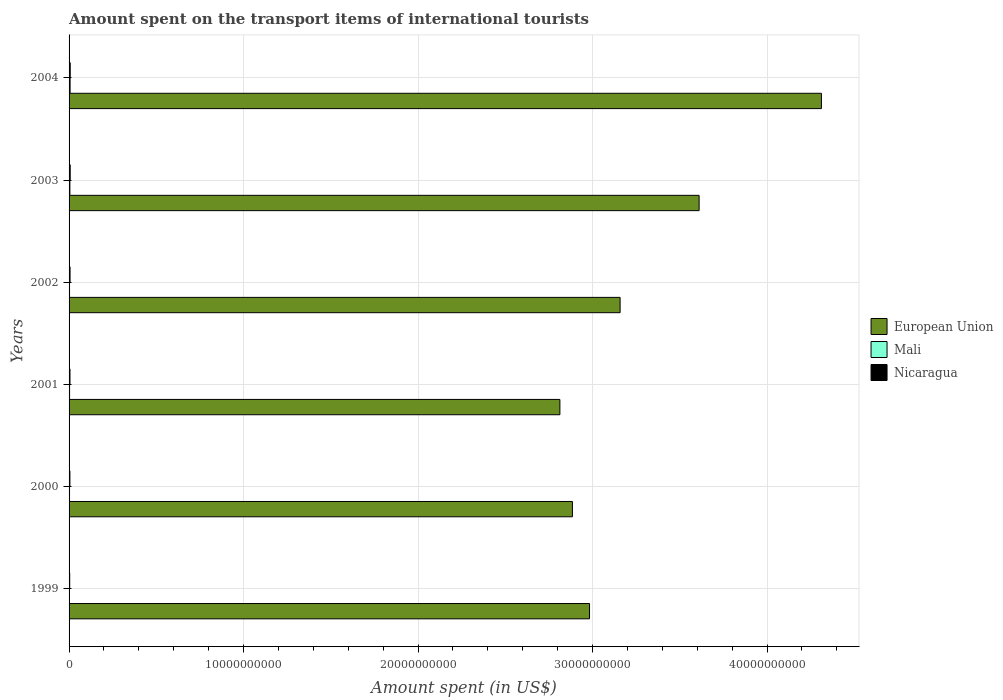How many different coloured bars are there?
Make the answer very short. 3. Are the number of bars per tick equal to the number of legend labels?
Your answer should be compact. Yes. Are the number of bars on each tick of the Y-axis equal?
Provide a short and direct response. Yes. How many bars are there on the 4th tick from the top?
Provide a short and direct response. 3. What is the label of the 4th group of bars from the top?
Give a very brief answer. 2001. In how many cases, is the number of bars for a given year not equal to the number of legend labels?
Give a very brief answer. 0. What is the amount spent on the transport items of international tourists in Mali in 1999?
Offer a very short reply. 2.50e+07. Across all years, what is the maximum amount spent on the transport items of international tourists in Mali?
Provide a short and direct response. 5.90e+07. Across all years, what is the minimum amount spent on the transport items of international tourists in Mali?
Offer a terse response. 2.50e+07. In which year was the amount spent on the transport items of international tourists in European Union minimum?
Offer a terse response. 2001. What is the total amount spent on the transport items of international tourists in Nicaragua in the graph?
Keep it short and to the point. 3.21e+08. What is the difference between the amount spent on the transport items of international tourists in Mali in 1999 and the amount spent on the transport items of international tourists in European Union in 2001?
Your answer should be very brief. -2.81e+1. What is the average amount spent on the transport items of international tourists in Mali per year?
Offer a very short reply. 3.52e+07. In the year 2003, what is the difference between the amount spent on the transport items of international tourists in Mali and amount spent on the transport items of international tourists in Nicaragua?
Provide a succinct answer. -1.80e+07. What is the ratio of the amount spent on the transport items of international tourists in European Union in 1999 to that in 2001?
Make the answer very short. 1.06. What is the difference between the highest and the second highest amount spent on the transport items of international tourists in European Union?
Ensure brevity in your answer.  7.01e+09. What is the difference between the highest and the lowest amount spent on the transport items of international tourists in Mali?
Give a very brief answer. 3.40e+07. In how many years, is the amount spent on the transport items of international tourists in Mali greater than the average amount spent on the transport items of international tourists in Mali taken over all years?
Provide a short and direct response. 2. What does the 2nd bar from the top in 2003 represents?
Ensure brevity in your answer.  Mali. What does the 2nd bar from the bottom in 2001 represents?
Ensure brevity in your answer.  Mali. How many years are there in the graph?
Provide a succinct answer. 6. Does the graph contain any zero values?
Ensure brevity in your answer.  No. How are the legend labels stacked?
Your answer should be compact. Vertical. What is the title of the graph?
Make the answer very short. Amount spent on the transport items of international tourists. Does "Tajikistan" appear as one of the legend labels in the graph?
Offer a terse response. No. What is the label or title of the X-axis?
Make the answer very short. Amount spent (in US$). What is the Amount spent (in US$) in European Union in 1999?
Offer a very short reply. 2.98e+1. What is the Amount spent (in US$) in Mali in 1999?
Provide a short and direct response. 2.50e+07. What is the Amount spent (in US$) of Nicaragua in 1999?
Offer a terse response. 3.60e+07. What is the Amount spent (in US$) of European Union in 2000?
Provide a short and direct response. 2.88e+1. What is the Amount spent (in US$) in Mali in 2000?
Ensure brevity in your answer.  2.60e+07. What is the Amount spent (in US$) of Nicaragua in 2000?
Make the answer very short. 4.80e+07. What is the Amount spent (in US$) of European Union in 2001?
Provide a short and direct response. 2.81e+1. What is the Amount spent (in US$) in Mali in 2001?
Your answer should be very brief. 2.90e+07. What is the Amount spent (in US$) of Nicaragua in 2001?
Offer a very short reply. 5.20e+07. What is the Amount spent (in US$) of European Union in 2002?
Provide a succinct answer. 3.16e+1. What is the Amount spent (in US$) in Mali in 2002?
Make the answer very short. 2.60e+07. What is the Amount spent (in US$) of Nicaragua in 2002?
Your answer should be very brief. 5.60e+07. What is the Amount spent (in US$) in European Union in 2003?
Your answer should be compact. 3.61e+1. What is the Amount spent (in US$) in Mali in 2003?
Offer a terse response. 4.60e+07. What is the Amount spent (in US$) in Nicaragua in 2003?
Provide a short and direct response. 6.40e+07. What is the Amount spent (in US$) in European Union in 2004?
Your response must be concise. 4.31e+1. What is the Amount spent (in US$) in Mali in 2004?
Offer a very short reply. 5.90e+07. What is the Amount spent (in US$) of Nicaragua in 2004?
Provide a succinct answer. 6.50e+07. Across all years, what is the maximum Amount spent (in US$) in European Union?
Your response must be concise. 4.31e+1. Across all years, what is the maximum Amount spent (in US$) in Mali?
Make the answer very short. 5.90e+07. Across all years, what is the maximum Amount spent (in US$) in Nicaragua?
Provide a short and direct response. 6.50e+07. Across all years, what is the minimum Amount spent (in US$) in European Union?
Make the answer very short. 2.81e+1. Across all years, what is the minimum Amount spent (in US$) of Mali?
Ensure brevity in your answer.  2.50e+07. Across all years, what is the minimum Amount spent (in US$) of Nicaragua?
Ensure brevity in your answer.  3.60e+07. What is the total Amount spent (in US$) of European Union in the graph?
Your answer should be very brief. 1.98e+11. What is the total Amount spent (in US$) in Mali in the graph?
Your answer should be compact. 2.11e+08. What is the total Amount spent (in US$) of Nicaragua in the graph?
Make the answer very short. 3.21e+08. What is the difference between the Amount spent (in US$) of European Union in 1999 and that in 2000?
Your answer should be very brief. 9.80e+08. What is the difference between the Amount spent (in US$) in Mali in 1999 and that in 2000?
Offer a very short reply. -1.00e+06. What is the difference between the Amount spent (in US$) of Nicaragua in 1999 and that in 2000?
Provide a succinct answer. -1.20e+07. What is the difference between the Amount spent (in US$) in European Union in 1999 and that in 2001?
Give a very brief answer. 1.70e+09. What is the difference between the Amount spent (in US$) in Nicaragua in 1999 and that in 2001?
Provide a short and direct response. -1.60e+07. What is the difference between the Amount spent (in US$) of European Union in 1999 and that in 2002?
Provide a succinct answer. -1.75e+09. What is the difference between the Amount spent (in US$) of Nicaragua in 1999 and that in 2002?
Your answer should be very brief. -2.00e+07. What is the difference between the Amount spent (in US$) in European Union in 1999 and that in 2003?
Give a very brief answer. -6.28e+09. What is the difference between the Amount spent (in US$) of Mali in 1999 and that in 2003?
Your answer should be compact. -2.10e+07. What is the difference between the Amount spent (in US$) of Nicaragua in 1999 and that in 2003?
Provide a succinct answer. -2.80e+07. What is the difference between the Amount spent (in US$) in European Union in 1999 and that in 2004?
Keep it short and to the point. -1.33e+1. What is the difference between the Amount spent (in US$) of Mali in 1999 and that in 2004?
Ensure brevity in your answer.  -3.40e+07. What is the difference between the Amount spent (in US$) in Nicaragua in 1999 and that in 2004?
Ensure brevity in your answer.  -2.90e+07. What is the difference between the Amount spent (in US$) of European Union in 2000 and that in 2001?
Ensure brevity in your answer.  7.18e+08. What is the difference between the Amount spent (in US$) of Mali in 2000 and that in 2001?
Your response must be concise. -3.00e+06. What is the difference between the Amount spent (in US$) in European Union in 2000 and that in 2002?
Offer a very short reply. -2.73e+09. What is the difference between the Amount spent (in US$) of Mali in 2000 and that in 2002?
Your answer should be very brief. 0. What is the difference between the Amount spent (in US$) in Nicaragua in 2000 and that in 2002?
Provide a short and direct response. -8.00e+06. What is the difference between the Amount spent (in US$) of European Union in 2000 and that in 2003?
Ensure brevity in your answer.  -7.26e+09. What is the difference between the Amount spent (in US$) in Mali in 2000 and that in 2003?
Your answer should be very brief. -2.00e+07. What is the difference between the Amount spent (in US$) in Nicaragua in 2000 and that in 2003?
Keep it short and to the point. -1.60e+07. What is the difference between the Amount spent (in US$) in European Union in 2000 and that in 2004?
Offer a terse response. -1.43e+1. What is the difference between the Amount spent (in US$) of Mali in 2000 and that in 2004?
Provide a short and direct response. -3.30e+07. What is the difference between the Amount spent (in US$) in Nicaragua in 2000 and that in 2004?
Keep it short and to the point. -1.70e+07. What is the difference between the Amount spent (in US$) of European Union in 2001 and that in 2002?
Provide a short and direct response. -3.45e+09. What is the difference between the Amount spent (in US$) of Mali in 2001 and that in 2002?
Ensure brevity in your answer.  3.00e+06. What is the difference between the Amount spent (in US$) in Nicaragua in 2001 and that in 2002?
Your answer should be compact. -4.00e+06. What is the difference between the Amount spent (in US$) in European Union in 2001 and that in 2003?
Make the answer very short. -7.98e+09. What is the difference between the Amount spent (in US$) of Mali in 2001 and that in 2003?
Give a very brief answer. -1.70e+07. What is the difference between the Amount spent (in US$) in Nicaragua in 2001 and that in 2003?
Your answer should be compact. -1.20e+07. What is the difference between the Amount spent (in US$) of European Union in 2001 and that in 2004?
Provide a succinct answer. -1.50e+1. What is the difference between the Amount spent (in US$) of Mali in 2001 and that in 2004?
Your response must be concise. -3.00e+07. What is the difference between the Amount spent (in US$) of Nicaragua in 2001 and that in 2004?
Your answer should be very brief. -1.30e+07. What is the difference between the Amount spent (in US$) in European Union in 2002 and that in 2003?
Your answer should be compact. -4.53e+09. What is the difference between the Amount spent (in US$) in Mali in 2002 and that in 2003?
Your answer should be very brief. -2.00e+07. What is the difference between the Amount spent (in US$) of Nicaragua in 2002 and that in 2003?
Make the answer very short. -8.00e+06. What is the difference between the Amount spent (in US$) in European Union in 2002 and that in 2004?
Your answer should be compact. -1.15e+1. What is the difference between the Amount spent (in US$) of Mali in 2002 and that in 2004?
Give a very brief answer. -3.30e+07. What is the difference between the Amount spent (in US$) of Nicaragua in 2002 and that in 2004?
Keep it short and to the point. -9.00e+06. What is the difference between the Amount spent (in US$) in European Union in 2003 and that in 2004?
Provide a succinct answer. -7.01e+09. What is the difference between the Amount spent (in US$) in Mali in 2003 and that in 2004?
Provide a short and direct response. -1.30e+07. What is the difference between the Amount spent (in US$) in Nicaragua in 2003 and that in 2004?
Ensure brevity in your answer.  -1.00e+06. What is the difference between the Amount spent (in US$) of European Union in 1999 and the Amount spent (in US$) of Mali in 2000?
Keep it short and to the point. 2.98e+1. What is the difference between the Amount spent (in US$) in European Union in 1999 and the Amount spent (in US$) in Nicaragua in 2000?
Your answer should be compact. 2.98e+1. What is the difference between the Amount spent (in US$) of Mali in 1999 and the Amount spent (in US$) of Nicaragua in 2000?
Keep it short and to the point. -2.30e+07. What is the difference between the Amount spent (in US$) in European Union in 1999 and the Amount spent (in US$) in Mali in 2001?
Give a very brief answer. 2.98e+1. What is the difference between the Amount spent (in US$) in European Union in 1999 and the Amount spent (in US$) in Nicaragua in 2001?
Keep it short and to the point. 2.98e+1. What is the difference between the Amount spent (in US$) in Mali in 1999 and the Amount spent (in US$) in Nicaragua in 2001?
Your answer should be compact. -2.70e+07. What is the difference between the Amount spent (in US$) in European Union in 1999 and the Amount spent (in US$) in Mali in 2002?
Offer a very short reply. 2.98e+1. What is the difference between the Amount spent (in US$) of European Union in 1999 and the Amount spent (in US$) of Nicaragua in 2002?
Give a very brief answer. 2.98e+1. What is the difference between the Amount spent (in US$) of Mali in 1999 and the Amount spent (in US$) of Nicaragua in 2002?
Provide a succinct answer. -3.10e+07. What is the difference between the Amount spent (in US$) in European Union in 1999 and the Amount spent (in US$) in Mali in 2003?
Keep it short and to the point. 2.98e+1. What is the difference between the Amount spent (in US$) of European Union in 1999 and the Amount spent (in US$) of Nicaragua in 2003?
Ensure brevity in your answer.  2.98e+1. What is the difference between the Amount spent (in US$) in Mali in 1999 and the Amount spent (in US$) in Nicaragua in 2003?
Give a very brief answer. -3.90e+07. What is the difference between the Amount spent (in US$) of European Union in 1999 and the Amount spent (in US$) of Mali in 2004?
Provide a short and direct response. 2.98e+1. What is the difference between the Amount spent (in US$) of European Union in 1999 and the Amount spent (in US$) of Nicaragua in 2004?
Give a very brief answer. 2.98e+1. What is the difference between the Amount spent (in US$) of Mali in 1999 and the Amount spent (in US$) of Nicaragua in 2004?
Your response must be concise. -4.00e+07. What is the difference between the Amount spent (in US$) in European Union in 2000 and the Amount spent (in US$) in Mali in 2001?
Your answer should be very brief. 2.88e+1. What is the difference between the Amount spent (in US$) of European Union in 2000 and the Amount spent (in US$) of Nicaragua in 2001?
Offer a terse response. 2.88e+1. What is the difference between the Amount spent (in US$) of Mali in 2000 and the Amount spent (in US$) of Nicaragua in 2001?
Give a very brief answer. -2.60e+07. What is the difference between the Amount spent (in US$) of European Union in 2000 and the Amount spent (in US$) of Mali in 2002?
Give a very brief answer. 2.88e+1. What is the difference between the Amount spent (in US$) of European Union in 2000 and the Amount spent (in US$) of Nicaragua in 2002?
Your response must be concise. 2.88e+1. What is the difference between the Amount spent (in US$) in Mali in 2000 and the Amount spent (in US$) in Nicaragua in 2002?
Provide a succinct answer. -3.00e+07. What is the difference between the Amount spent (in US$) in European Union in 2000 and the Amount spent (in US$) in Mali in 2003?
Your answer should be compact. 2.88e+1. What is the difference between the Amount spent (in US$) in European Union in 2000 and the Amount spent (in US$) in Nicaragua in 2003?
Offer a terse response. 2.88e+1. What is the difference between the Amount spent (in US$) of Mali in 2000 and the Amount spent (in US$) of Nicaragua in 2003?
Your answer should be very brief. -3.80e+07. What is the difference between the Amount spent (in US$) of European Union in 2000 and the Amount spent (in US$) of Mali in 2004?
Provide a short and direct response. 2.88e+1. What is the difference between the Amount spent (in US$) in European Union in 2000 and the Amount spent (in US$) in Nicaragua in 2004?
Your response must be concise. 2.88e+1. What is the difference between the Amount spent (in US$) in Mali in 2000 and the Amount spent (in US$) in Nicaragua in 2004?
Offer a very short reply. -3.90e+07. What is the difference between the Amount spent (in US$) of European Union in 2001 and the Amount spent (in US$) of Mali in 2002?
Give a very brief answer. 2.81e+1. What is the difference between the Amount spent (in US$) of European Union in 2001 and the Amount spent (in US$) of Nicaragua in 2002?
Give a very brief answer. 2.81e+1. What is the difference between the Amount spent (in US$) in Mali in 2001 and the Amount spent (in US$) in Nicaragua in 2002?
Provide a succinct answer. -2.70e+07. What is the difference between the Amount spent (in US$) of European Union in 2001 and the Amount spent (in US$) of Mali in 2003?
Offer a very short reply. 2.81e+1. What is the difference between the Amount spent (in US$) of European Union in 2001 and the Amount spent (in US$) of Nicaragua in 2003?
Offer a very short reply. 2.81e+1. What is the difference between the Amount spent (in US$) in Mali in 2001 and the Amount spent (in US$) in Nicaragua in 2003?
Make the answer very short. -3.50e+07. What is the difference between the Amount spent (in US$) in European Union in 2001 and the Amount spent (in US$) in Mali in 2004?
Make the answer very short. 2.81e+1. What is the difference between the Amount spent (in US$) in European Union in 2001 and the Amount spent (in US$) in Nicaragua in 2004?
Provide a succinct answer. 2.81e+1. What is the difference between the Amount spent (in US$) of Mali in 2001 and the Amount spent (in US$) of Nicaragua in 2004?
Your answer should be very brief. -3.60e+07. What is the difference between the Amount spent (in US$) in European Union in 2002 and the Amount spent (in US$) in Mali in 2003?
Keep it short and to the point. 3.15e+1. What is the difference between the Amount spent (in US$) of European Union in 2002 and the Amount spent (in US$) of Nicaragua in 2003?
Provide a succinct answer. 3.15e+1. What is the difference between the Amount spent (in US$) in Mali in 2002 and the Amount spent (in US$) in Nicaragua in 2003?
Make the answer very short. -3.80e+07. What is the difference between the Amount spent (in US$) in European Union in 2002 and the Amount spent (in US$) in Mali in 2004?
Offer a terse response. 3.15e+1. What is the difference between the Amount spent (in US$) in European Union in 2002 and the Amount spent (in US$) in Nicaragua in 2004?
Make the answer very short. 3.15e+1. What is the difference between the Amount spent (in US$) of Mali in 2002 and the Amount spent (in US$) of Nicaragua in 2004?
Provide a short and direct response. -3.90e+07. What is the difference between the Amount spent (in US$) of European Union in 2003 and the Amount spent (in US$) of Mali in 2004?
Make the answer very short. 3.60e+1. What is the difference between the Amount spent (in US$) of European Union in 2003 and the Amount spent (in US$) of Nicaragua in 2004?
Provide a short and direct response. 3.60e+1. What is the difference between the Amount spent (in US$) of Mali in 2003 and the Amount spent (in US$) of Nicaragua in 2004?
Provide a succinct answer. -1.90e+07. What is the average Amount spent (in US$) in European Union per year?
Your answer should be compact. 3.29e+1. What is the average Amount spent (in US$) in Mali per year?
Your response must be concise. 3.52e+07. What is the average Amount spent (in US$) in Nicaragua per year?
Provide a short and direct response. 5.35e+07. In the year 1999, what is the difference between the Amount spent (in US$) in European Union and Amount spent (in US$) in Mali?
Your answer should be compact. 2.98e+1. In the year 1999, what is the difference between the Amount spent (in US$) of European Union and Amount spent (in US$) of Nicaragua?
Offer a terse response. 2.98e+1. In the year 1999, what is the difference between the Amount spent (in US$) of Mali and Amount spent (in US$) of Nicaragua?
Ensure brevity in your answer.  -1.10e+07. In the year 2000, what is the difference between the Amount spent (in US$) of European Union and Amount spent (in US$) of Mali?
Give a very brief answer. 2.88e+1. In the year 2000, what is the difference between the Amount spent (in US$) of European Union and Amount spent (in US$) of Nicaragua?
Your response must be concise. 2.88e+1. In the year 2000, what is the difference between the Amount spent (in US$) in Mali and Amount spent (in US$) in Nicaragua?
Provide a short and direct response. -2.20e+07. In the year 2001, what is the difference between the Amount spent (in US$) of European Union and Amount spent (in US$) of Mali?
Ensure brevity in your answer.  2.81e+1. In the year 2001, what is the difference between the Amount spent (in US$) in European Union and Amount spent (in US$) in Nicaragua?
Offer a very short reply. 2.81e+1. In the year 2001, what is the difference between the Amount spent (in US$) of Mali and Amount spent (in US$) of Nicaragua?
Your answer should be very brief. -2.30e+07. In the year 2002, what is the difference between the Amount spent (in US$) of European Union and Amount spent (in US$) of Mali?
Your answer should be very brief. 3.16e+1. In the year 2002, what is the difference between the Amount spent (in US$) in European Union and Amount spent (in US$) in Nicaragua?
Your answer should be compact. 3.15e+1. In the year 2002, what is the difference between the Amount spent (in US$) of Mali and Amount spent (in US$) of Nicaragua?
Provide a short and direct response. -3.00e+07. In the year 2003, what is the difference between the Amount spent (in US$) of European Union and Amount spent (in US$) of Mali?
Offer a terse response. 3.61e+1. In the year 2003, what is the difference between the Amount spent (in US$) of European Union and Amount spent (in US$) of Nicaragua?
Provide a succinct answer. 3.60e+1. In the year 2003, what is the difference between the Amount spent (in US$) of Mali and Amount spent (in US$) of Nicaragua?
Offer a very short reply. -1.80e+07. In the year 2004, what is the difference between the Amount spent (in US$) in European Union and Amount spent (in US$) in Mali?
Your answer should be compact. 4.31e+1. In the year 2004, what is the difference between the Amount spent (in US$) in European Union and Amount spent (in US$) in Nicaragua?
Make the answer very short. 4.30e+1. In the year 2004, what is the difference between the Amount spent (in US$) of Mali and Amount spent (in US$) of Nicaragua?
Offer a terse response. -6.00e+06. What is the ratio of the Amount spent (in US$) in European Union in 1999 to that in 2000?
Keep it short and to the point. 1.03. What is the ratio of the Amount spent (in US$) of Mali in 1999 to that in 2000?
Your response must be concise. 0.96. What is the ratio of the Amount spent (in US$) in Nicaragua in 1999 to that in 2000?
Make the answer very short. 0.75. What is the ratio of the Amount spent (in US$) in European Union in 1999 to that in 2001?
Offer a terse response. 1.06. What is the ratio of the Amount spent (in US$) of Mali in 1999 to that in 2001?
Provide a short and direct response. 0.86. What is the ratio of the Amount spent (in US$) in Nicaragua in 1999 to that in 2001?
Your answer should be compact. 0.69. What is the ratio of the Amount spent (in US$) of European Union in 1999 to that in 2002?
Give a very brief answer. 0.94. What is the ratio of the Amount spent (in US$) of Mali in 1999 to that in 2002?
Your answer should be very brief. 0.96. What is the ratio of the Amount spent (in US$) of Nicaragua in 1999 to that in 2002?
Your answer should be compact. 0.64. What is the ratio of the Amount spent (in US$) of European Union in 1999 to that in 2003?
Offer a very short reply. 0.83. What is the ratio of the Amount spent (in US$) in Mali in 1999 to that in 2003?
Ensure brevity in your answer.  0.54. What is the ratio of the Amount spent (in US$) in Nicaragua in 1999 to that in 2003?
Keep it short and to the point. 0.56. What is the ratio of the Amount spent (in US$) in European Union in 1999 to that in 2004?
Offer a very short reply. 0.69. What is the ratio of the Amount spent (in US$) in Mali in 1999 to that in 2004?
Your response must be concise. 0.42. What is the ratio of the Amount spent (in US$) of Nicaragua in 1999 to that in 2004?
Provide a succinct answer. 0.55. What is the ratio of the Amount spent (in US$) of European Union in 2000 to that in 2001?
Your response must be concise. 1.03. What is the ratio of the Amount spent (in US$) in Mali in 2000 to that in 2001?
Your answer should be very brief. 0.9. What is the ratio of the Amount spent (in US$) in Nicaragua in 2000 to that in 2001?
Offer a terse response. 0.92. What is the ratio of the Amount spent (in US$) in European Union in 2000 to that in 2002?
Offer a terse response. 0.91. What is the ratio of the Amount spent (in US$) in Mali in 2000 to that in 2002?
Ensure brevity in your answer.  1. What is the ratio of the Amount spent (in US$) in Nicaragua in 2000 to that in 2002?
Offer a very short reply. 0.86. What is the ratio of the Amount spent (in US$) of European Union in 2000 to that in 2003?
Ensure brevity in your answer.  0.8. What is the ratio of the Amount spent (in US$) in Mali in 2000 to that in 2003?
Provide a succinct answer. 0.57. What is the ratio of the Amount spent (in US$) of Nicaragua in 2000 to that in 2003?
Offer a very short reply. 0.75. What is the ratio of the Amount spent (in US$) of European Union in 2000 to that in 2004?
Your response must be concise. 0.67. What is the ratio of the Amount spent (in US$) in Mali in 2000 to that in 2004?
Your answer should be very brief. 0.44. What is the ratio of the Amount spent (in US$) in Nicaragua in 2000 to that in 2004?
Give a very brief answer. 0.74. What is the ratio of the Amount spent (in US$) in European Union in 2001 to that in 2002?
Your answer should be very brief. 0.89. What is the ratio of the Amount spent (in US$) of Mali in 2001 to that in 2002?
Make the answer very short. 1.12. What is the ratio of the Amount spent (in US$) of European Union in 2001 to that in 2003?
Ensure brevity in your answer.  0.78. What is the ratio of the Amount spent (in US$) in Mali in 2001 to that in 2003?
Provide a succinct answer. 0.63. What is the ratio of the Amount spent (in US$) in Nicaragua in 2001 to that in 2003?
Ensure brevity in your answer.  0.81. What is the ratio of the Amount spent (in US$) of European Union in 2001 to that in 2004?
Make the answer very short. 0.65. What is the ratio of the Amount spent (in US$) in Mali in 2001 to that in 2004?
Your response must be concise. 0.49. What is the ratio of the Amount spent (in US$) in European Union in 2002 to that in 2003?
Your answer should be compact. 0.87. What is the ratio of the Amount spent (in US$) in Mali in 2002 to that in 2003?
Provide a succinct answer. 0.57. What is the ratio of the Amount spent (in US$) in Nicaragua in 2002 to that in 2003?
Offer a terse response. 0.88. What is the ratio of the Amount spent (in US$) of European Union in 2002 to that in 2004?
Make the answer very short. 0.73. What is the ratio of the Amount spent (in US$) of Mali in 2002 to that in 2004?
Your response must be concise. 0.44. What is the ratio of the Amount spent (in US$) in Nicaragua in 2002 to that in 2004?
Your response must be concise. 0.86. What is the ratio of the Amount spent (in US$) of European Union in 2003 to that in 2004?
Your answer should be compact. 0.84. What is the ratio of the Amount spent (in US$) in Mali in 2003 to that in 2004?
Your answer should be very brief. 0.78. What is the ratio of the Amount spent (in US$) of Nicaragua in 2003 to that in 2004?
Give a very brief answer. 0.98. What is the difference between the highest and the second highest Amount spent (in US$) of European Union?
Your answer should be compact. 7.01e+09. What is the difference between the highest and the second highest Amount spent (in US$) of Mali?
Offer a very short reply. 1.30e+07. What is the difference between the highest and the lowest Amount spent (in US$) in European Union?
Your answer should be very brief. 1.50e+1. What is the difference between the highest and the lowest Amount spent (in US$) of Mali?
Give a very brief answer. 3.40e+07. What is the difference between the highest and the lowest Amount spent (in US$) of Nicaragua?
Your answer should be very brief. 2.90e+07. 